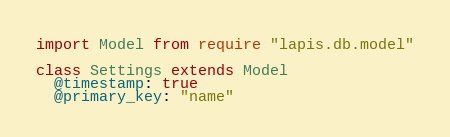Convert code to text. <code><loc_0><loc_0><loc_500><loc_500><_MoonScript_>import Model from require "lapis.db.model"

class Settings extends Model
  @timestamp: true
  @primary_key: "name"
</code> 